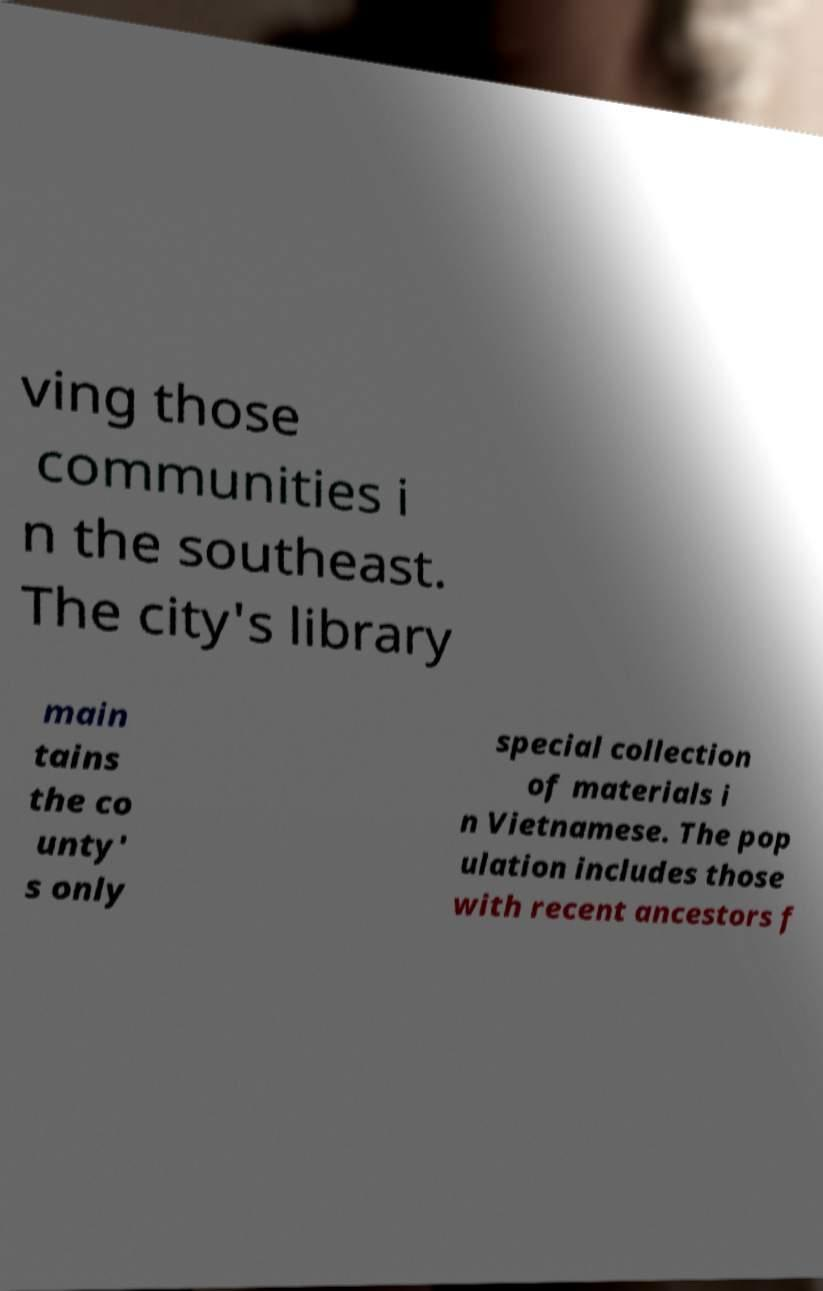I need the written content from this picture converted into text. Can you do that? ving those communities i n the southeast. The city's library main tains the co unty' s only special collection of materials i n Vietnamese. The pop ulation includes those with recent ancestors f 